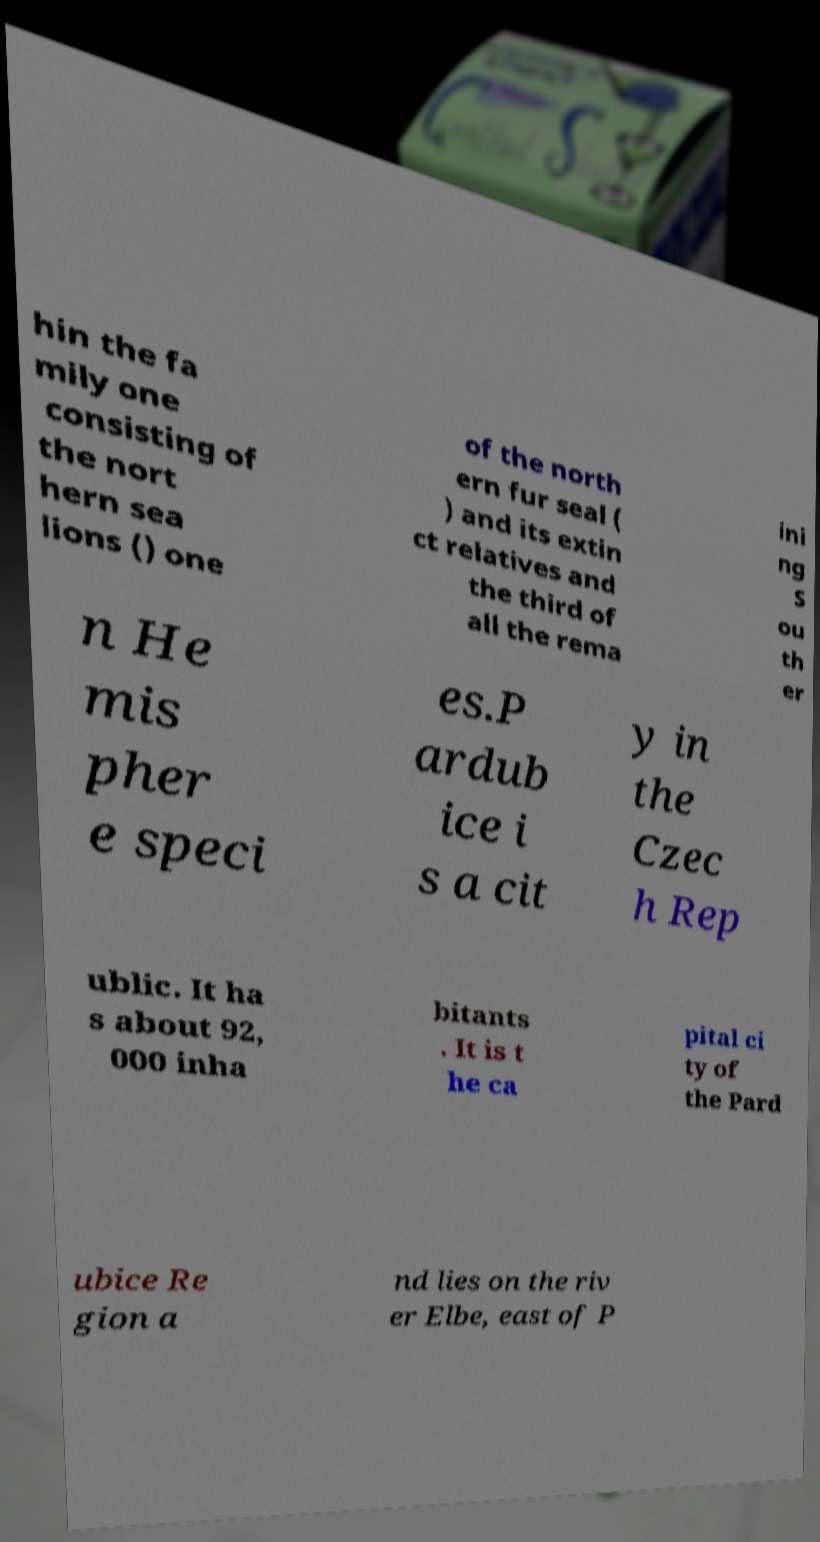For documentation purposes, I need the text within this image transcribed. Could you provide that? hin the fa mily one consisting of the nort hern sea lions () one of the north ern fur seal ( ) and its extin ct relatives and the third of all the rema ini ng S ou th er n He mis pher e speci es.P ardub ice i s a cit y in the Czec h Rep ublic. It ha s about 92, 000 inha bitants . It is t he ca pital ci ty of the Pard ubice Re gion a nd lies on the riv er Elbe, east of P 